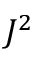<formula> <loc_0><loc_0><loc_500><loc_500>J ^ { 2 }</formula> 